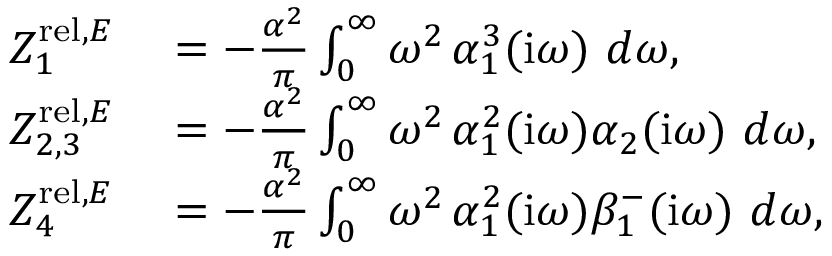Convert formula to latex. <formula><loc_0><loc_0><loc_500><loc_500>\begin{array} { r l } { Z _ { 1 } ^ { r e l , E } } & = - \frac { \alpha ^ { 2 } } \pi \int _ { 0 } ^ { \infty } \omega ^ { 2 } \, \alpha _ { 1 } ^ { 3 } ( i \omega ) d \omega , } \\ { Z _ { 2 , 3 } ^ { r e l , E } } & = - \frac { \alpha ^ { 2 } } \pi \int _ { 0 } ^ { \infty } \omega ^ { 2 } \, \alpha _ { 1 } ^ { 2 } ( i \omega ) \alpha _ { 2 } ( i \omega ) d \omega , } \\ { Z _ { 4 } ^ { r e l , E } } & = - \frac { \alpha ^ { 2 } } \pi \int _ { 0 } ^ { \infty } \omega ^ { 2 } \, \alpha _ { 1 } ^ { 2 } ( i \omega ) \beta _ { 1 } ^ { - } ( i \omega ) d \omega , } \end{array}</formula> 